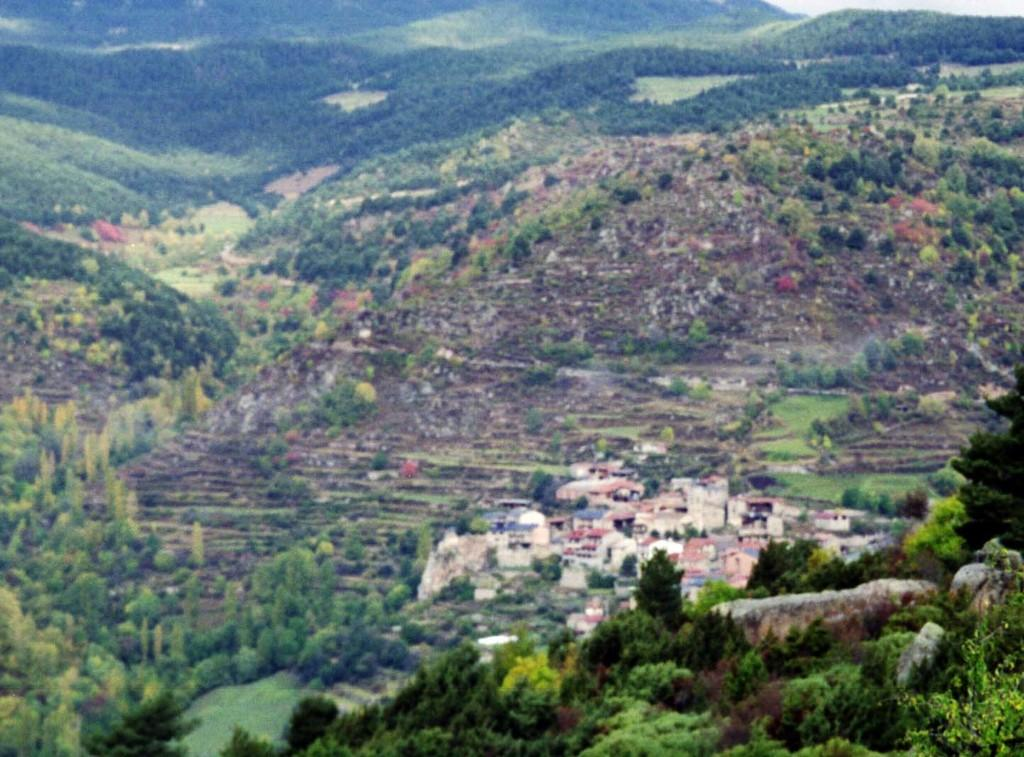What type of structures can be seen in the image? There are houses in the image. What natural elements are present in the image? There are trees and hills in the image. Where are the rocks located in the image? Rocks are present on the right side bottom of the image. Can you see a plastic playground in the image? There is no plastic playground present in the image. Who is the friend that can be seen in the image? There is no friend depicted in the image. 